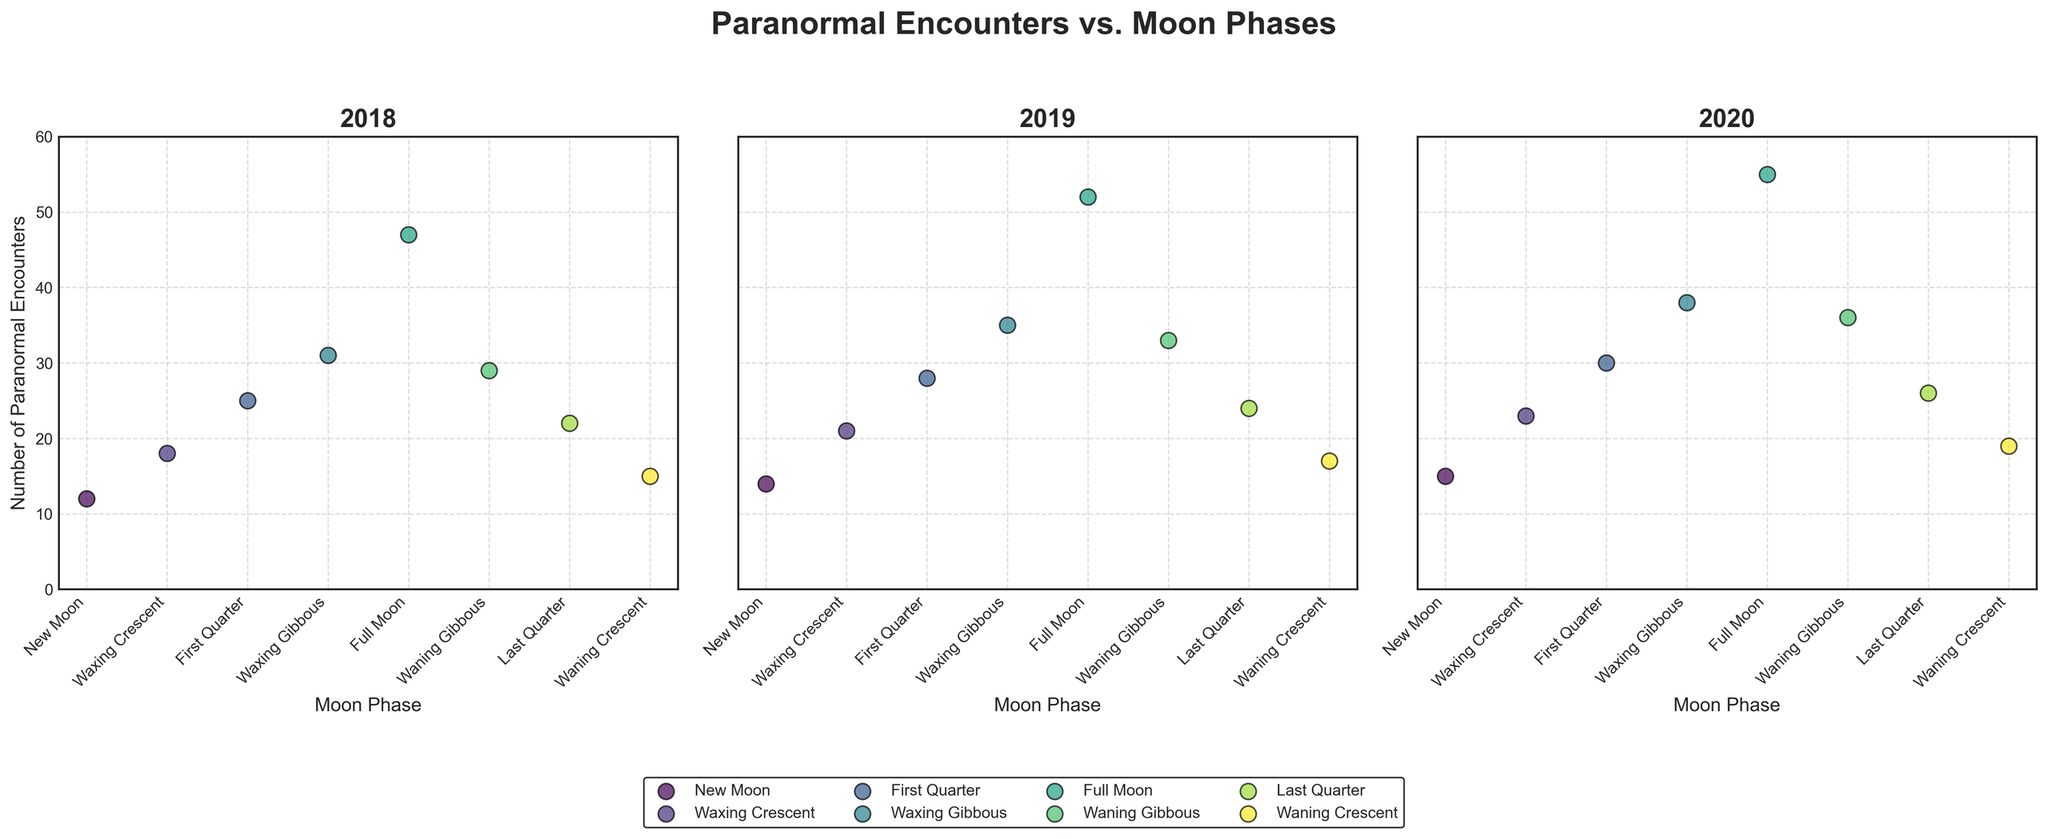What's the title of the plot? The title is located at the top center of the figure and usually describes the main point of the visual. According to the provided details, the title is "Paranormal Encounters vs. Moon Phases".
Answer: Paranormal Encounters vs. Moon Phases What is the y-axis label? The y-axis label is generally positioned along the vertical axis and describes what the y-axis values represent. From the given details, the y-axis label is "Number of Paranormal Encounters".
Answer: Number of Paranormal Encounters Which moon phase had the highest number of paranormal encounters in 2020? Looking at the scatter plot for the year 2020 within the subplot, identify the data point with the highest y-value. The Full Moon phase had the highest y-value, indicating it had the highest number of paranormal encounters.
Answer: Full Moon How many phases of the moon are represented in each scatter plot subplot? Each subplot corresponds to a year and contains data points for different moon phases. By counting the unique moon phases, we find that there are 8 phases represented: New Moon, Waxing Crescent, First Quarter, Waxing Gibbous, Full Moon, Waning Gibbous, Last Quarter, and Waning Crescent.
Answer: 8 Which year had the lowest number of paranormal encounters during a New Moon phase? Compare the scatter plots of each year's subplot for the New Moon phase. The year with the lowest y-value for the New Moon phase needs to be identified, which in this case is the year 2018 with 12 encounters.
Answer: 2018 Compare the number of paranormal encounters during the First Quarter phase across all years. Which year had the highest number? For each year's subplot, find the data point corresponding to the First Quarter phase and compare their y-values. The year 2020 has the highest number of paranormal encounters for the First Quarter phase, at 30 encounters.
Answer: 2020 What is the difference in the number of paranormal encounters between the Full Moon phase and the New Moon phase in 2020? Locate the Full Moon and New Moon data points for the year 2020 subplot. The Full Moon has 55 encounters, and the New Moon has 15 encounters. Subtract the latter from the former: 55 - 15 = 40.
Answer: 40 Is there a general trend you observe in the number of paranormal encounters during the Full Moon phase across all three years? Examine the y-values for the Full Moon phase in each year's subplot. Paranormal encounters during the Full Moon phase increase from 47 in 2018 to 52 in 2019 and further to 55 in 2020.
Answer: The number of encounters increases Which location witnessed paranormal encounters during the Last Quarter phase in 2019? For the Last Quarter phase data point in the subplot for the year 2019, identify the location associated with this data point. The location is Loch Ness.
Answer: Loch Ness How many paranormal encounters were reported in Sedona during Waxing Crescent phase over all available years? Examine the data points in the subplots for each year corresponding to the Waxing Crescent phase and the location Sedona. The counts are 18 in 2018 and 23 in 2020. Summing these values: 18 + 23 = 41.
Answer: 41 